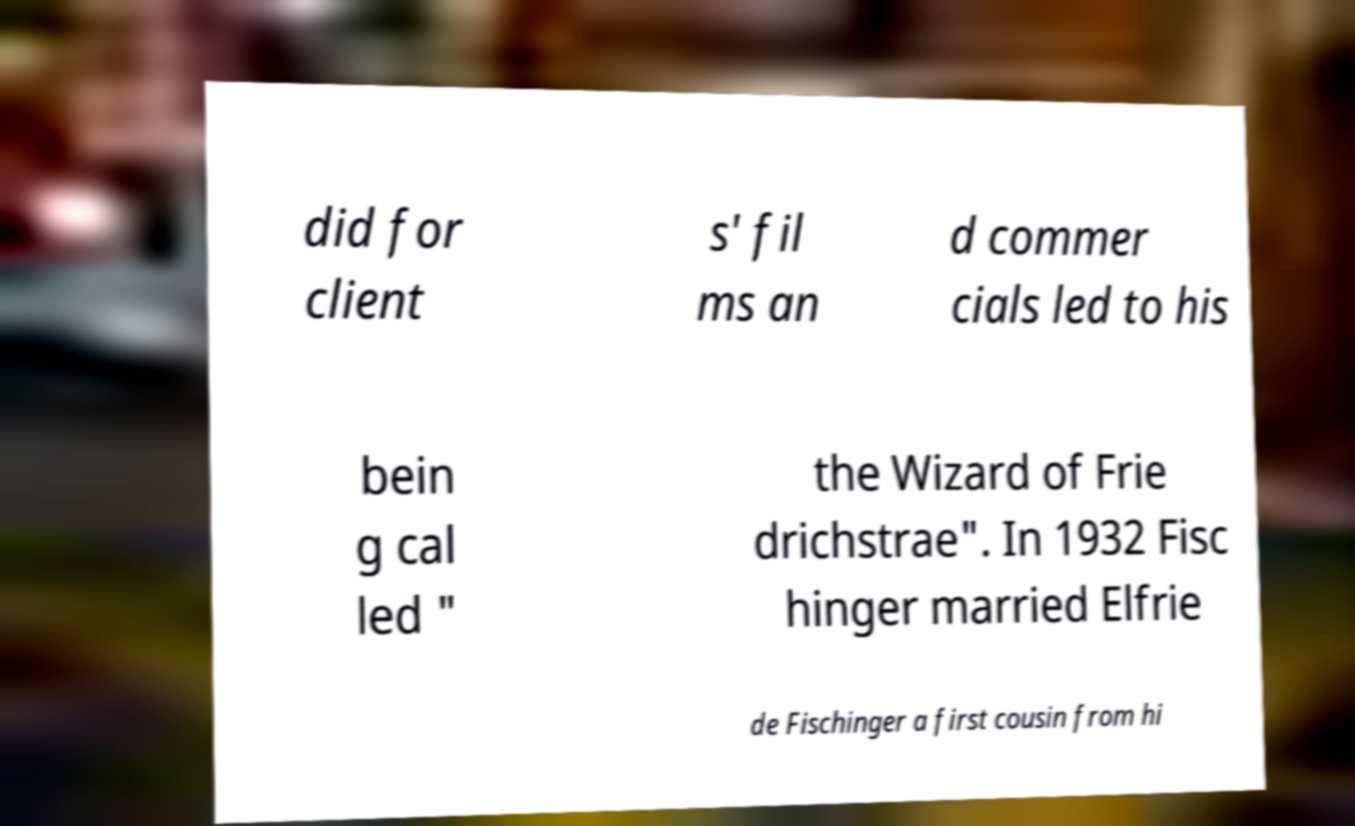I need the written content from this picture converted into text. Can you do that? did for client s' fil ms an d commer cials led to his bein g cal led " the Wizard of Frie drichstrae". In 1932 Fisc hinger married Elfrie de Fischinger a first cousin from hi 